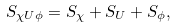Convert formula to latex. <formula><loc_0><loc_0><loc_500><loc_500>S _ { \chi U \phi } = S _ { \chi } + S _ { U } + S _ { \phi } ,</formula> 